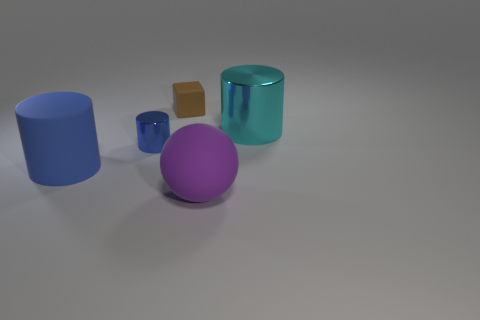Add 4 large cyan cylinders. How many objects exist? 9 Subtract all large cylinders. How many cylinders are left? 1 Subtract all blue cylinders. How many cylinders are left? 1 Subtract all yellow cylinders. Subtract all purple cubes. How many cylinders are left? 3 Subtract all gray cylinders. How many gray spheres are left? 0 Subtract all cyan things. Subtract all big purple metallic cylinders. How many objects are left? 4 Add 2 large blue objects. How many large blue objects are left? 3 Add 5 blue objects. How many blue objects exist? 7 Subtract 0 gray cubes. How many objects are left? 5 Subtract all cubes. How many objects are left? 4 